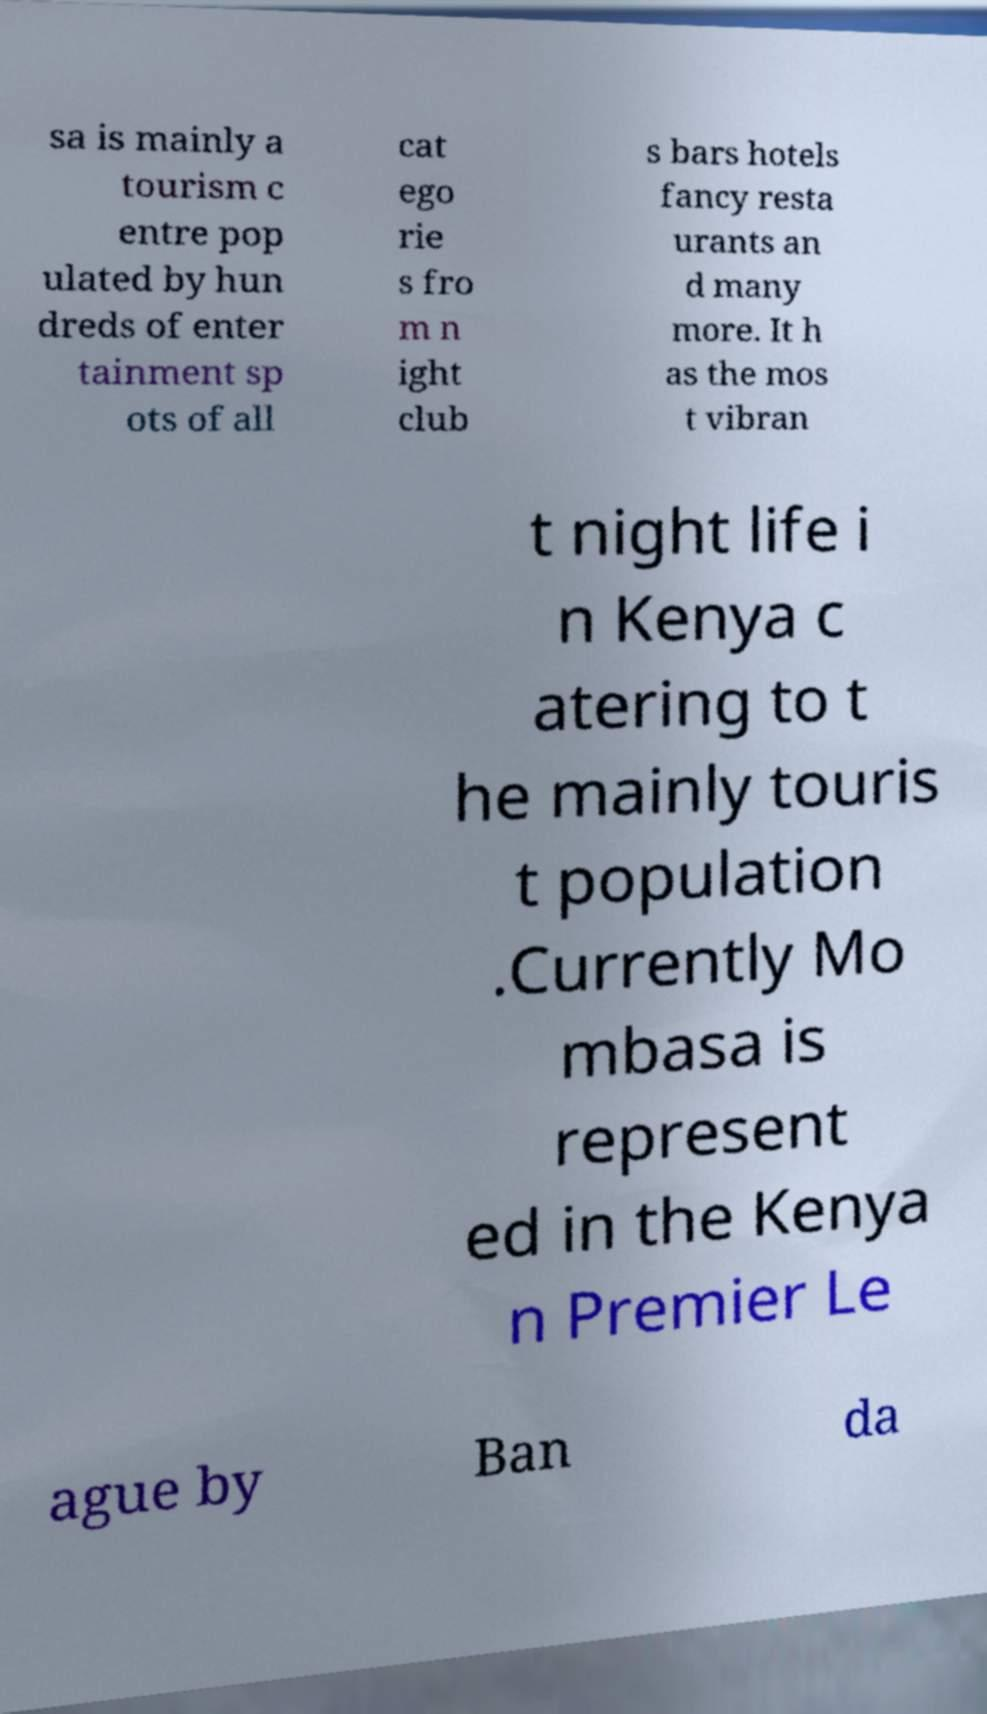What messages or text are displayed in this image? I need them in a readable, typed format. sa is mainly a tourism c entre pop ulated by hun dreds of enter tainment sp ots of all cat ego rie s fro m n ight club s bars hotels fancy resta urants an d many more. It h as the mos t vibran t night life i n Kenya c atering to t he mainly touris t population .Currently Mo mbasa is represent ed in the Kenya n Premier Le ague by Ban da 